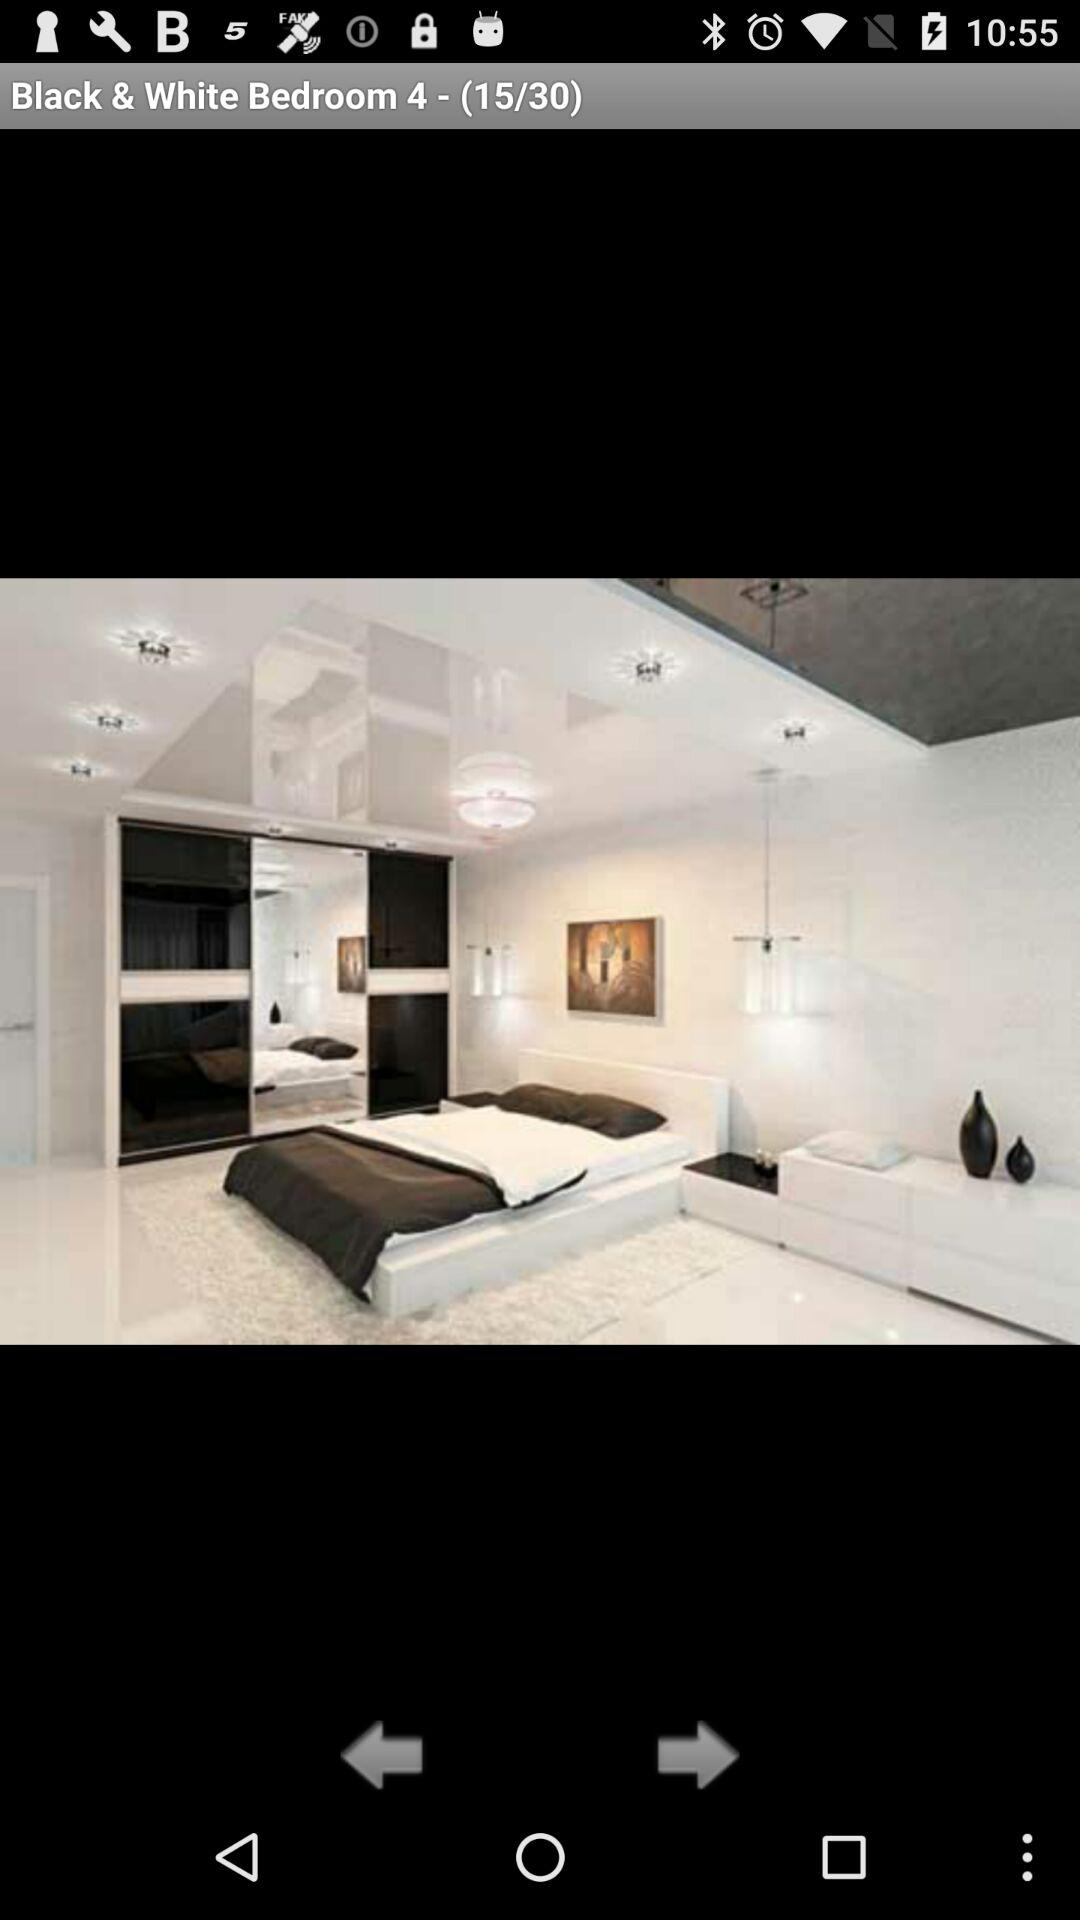At which picture number are we? You are at picture number 15. 